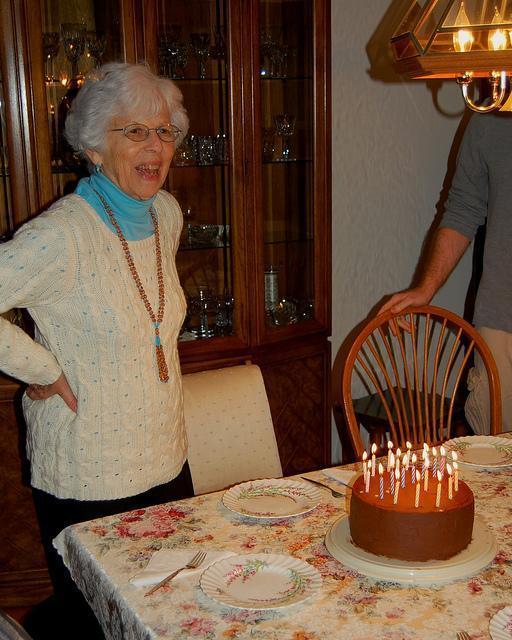How many cakes are there?
Give a very brief answer. 1. How many chairs are in the picture?
Give a very brief answer. 2. How many people can you see?
Give a very brief answer. 2. How many train cars are on the right of the man ?
Give a very brief answer. 0. 